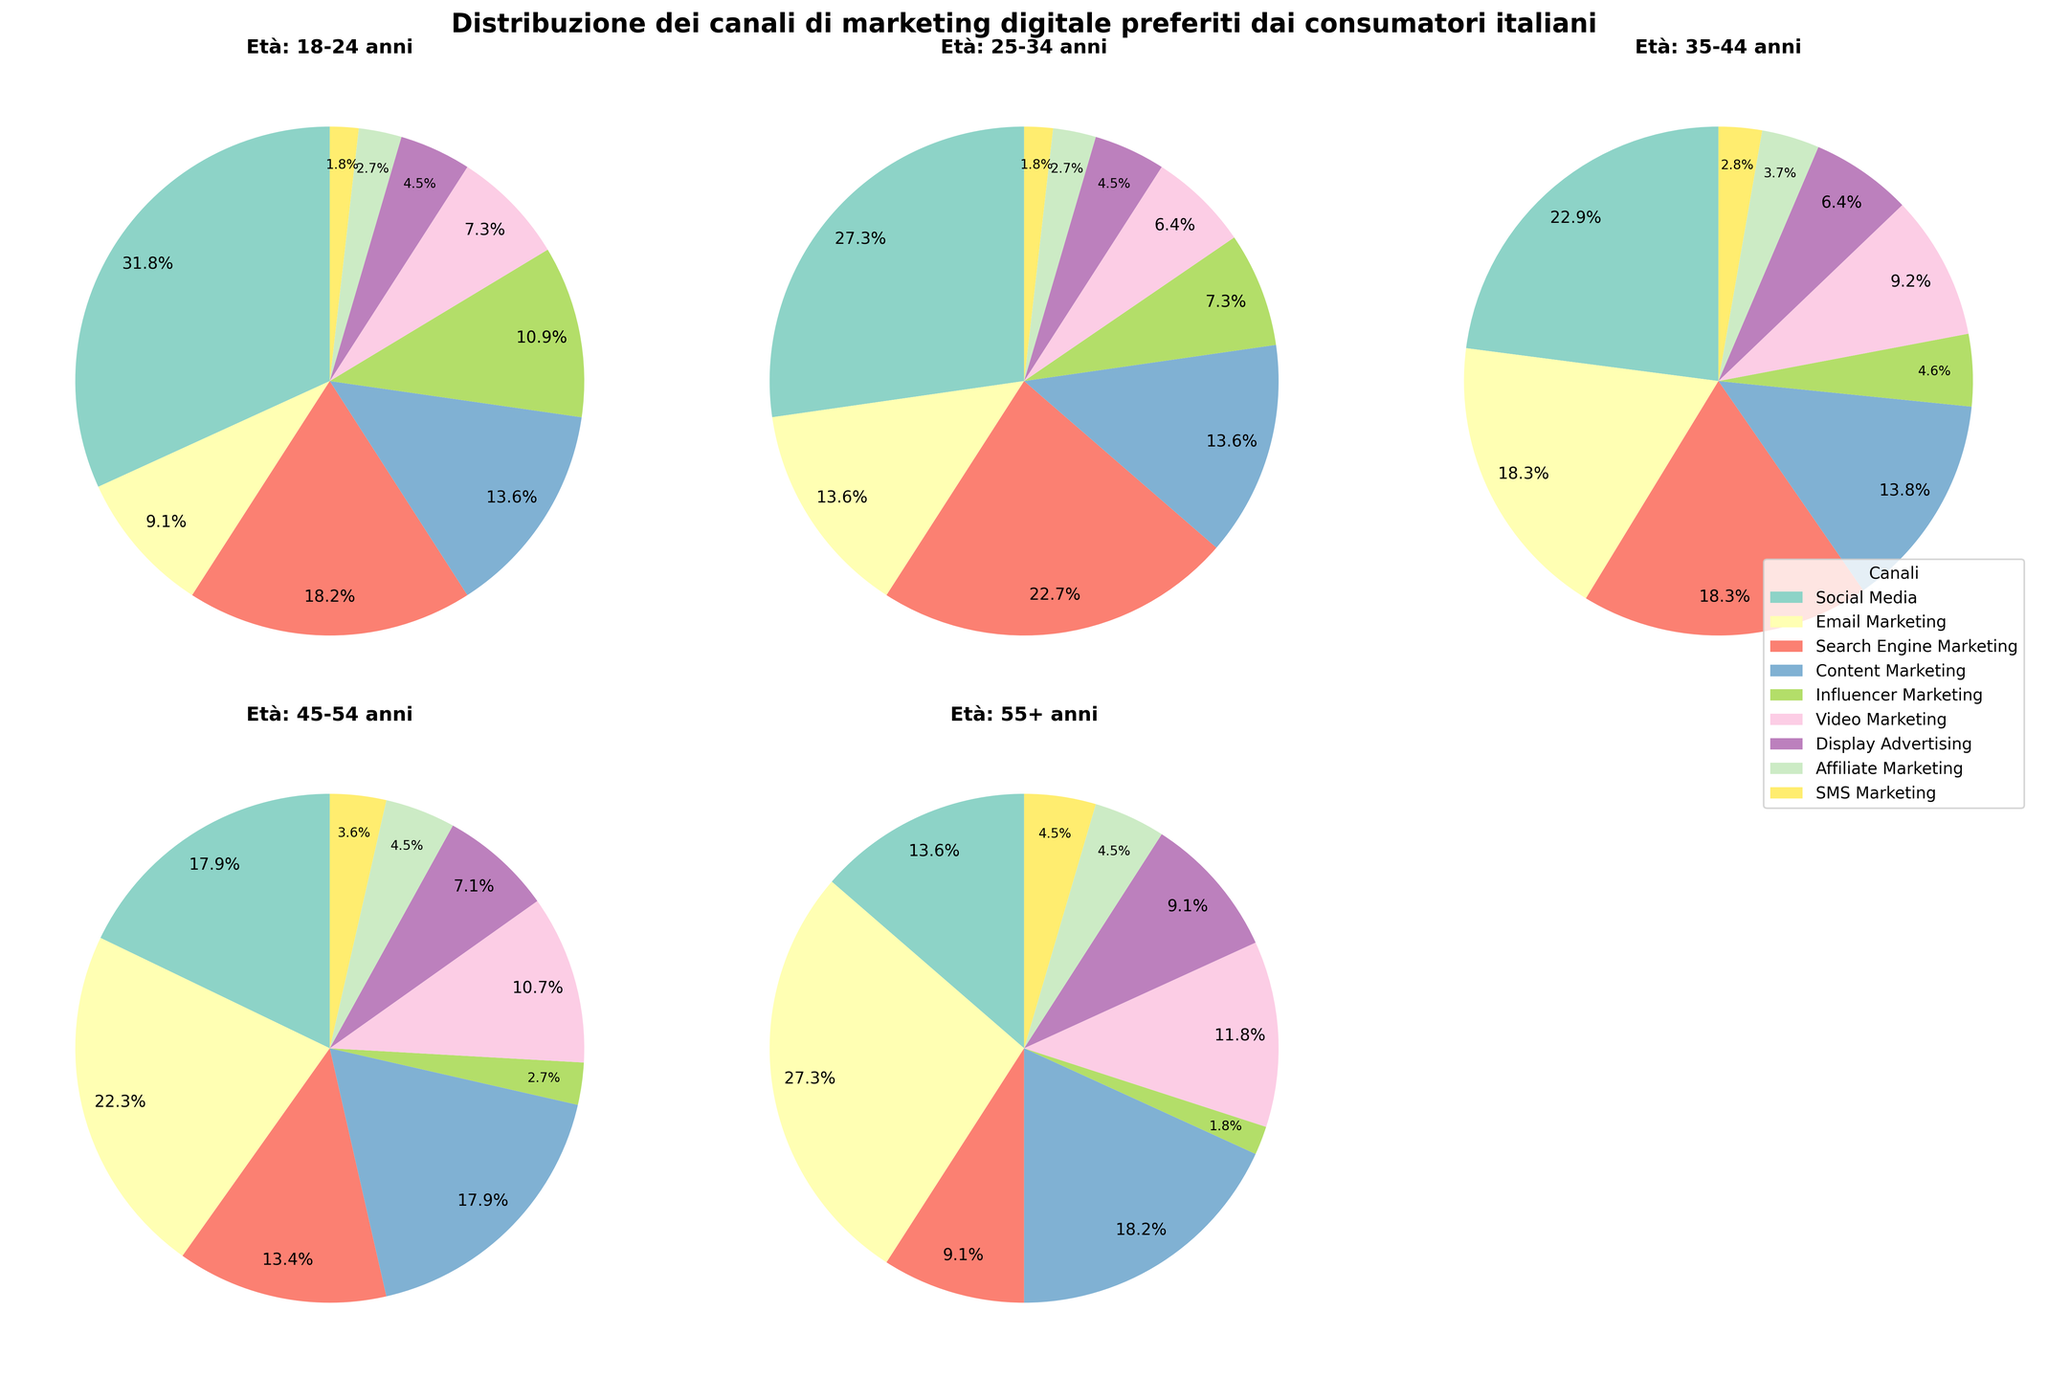What's the most preferred marketing channel for users aged 18-24? In the pie chart for the 18-24 age group, the largest slice represents the most preferred marketing channel. This slice is labeled as "Social Media."
Answer: Social Media Which age group prefers Email Marketing the most? Examine the slices labeled "Email Marketing" in each age group’s pie chart. The largest slice for Email Marketing is in the 55+ age group.
Answer: 55+ anni Compare Social Media preference between the 18-24 and 55+ age groups. Which group shows a higher preference? In the pie charts for 18-24 and 55+ age groups, the percentage for Social Media is 35% for 18-24 and 15% for 55+. Therefore, 18-24-year-olds show a higher preference.
Answer: 18-24 anni What is the total percentage of consumers aged 35-44 who prefer Search Engine Marketing and Video Marketing combined? Add the percentage slices for Search Engine Marketing (20%) and Video Marketing (10%) in the pie chart for the 35-44 age group.
Answer: 30% Which marketing channel has the least preference among users aged 45-54? Identify the smallest slice in the pie chart for the 45-54 age group. It corresponds to "Influencer Marketing," which has 3%.
Answer: Influencer Marketing Is Display Advertising more preferred by the age group 25-34 or 55+? Compare the slices labeled "Display Advertising" in the pie charts for 25-34 and 55+ age groups. The percentages are 5% and 10%, respectively.
Answer: 55+ anni What is the combined preference for Content Marketing across all age groups? Find the Content Marketing percentages in each pie chart (15%, 15%, 15%, 20%, 20%) and sum them up: 15% + 15% + 15% + 20% + 20% = 85%.
Answer: 85% Which age group shows the highest preference for Video Marketing? Look at the slices labeled "Video Marketing" in all age groups and identify the highest percentage, which is 13% in the 55+ age group.
Answer: 55+ anni Between the age groups 25-34 and 35-44, which has a higher percentage for Affiliate Marketing? Compare the percentages for Affiliate Marketing in the pie charts for 25-34 and 35-44 age groups. Both have 3% and 4% respectively, making 35-44 have a higher percentage.
Answer: 35-44 anni 